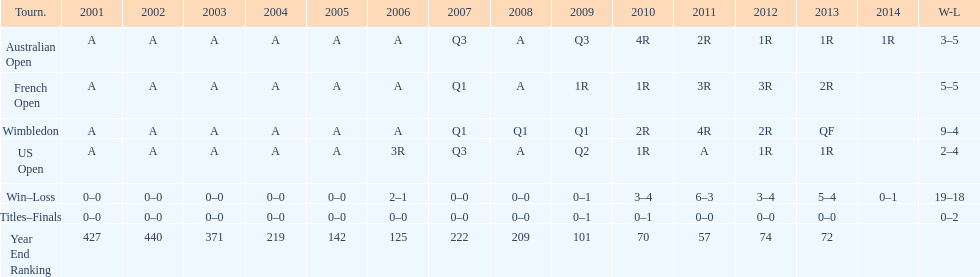Which years was a ranking below 200 achieved? 2005, 2006, 2009, 2010, 2011, 2012, 2013. 